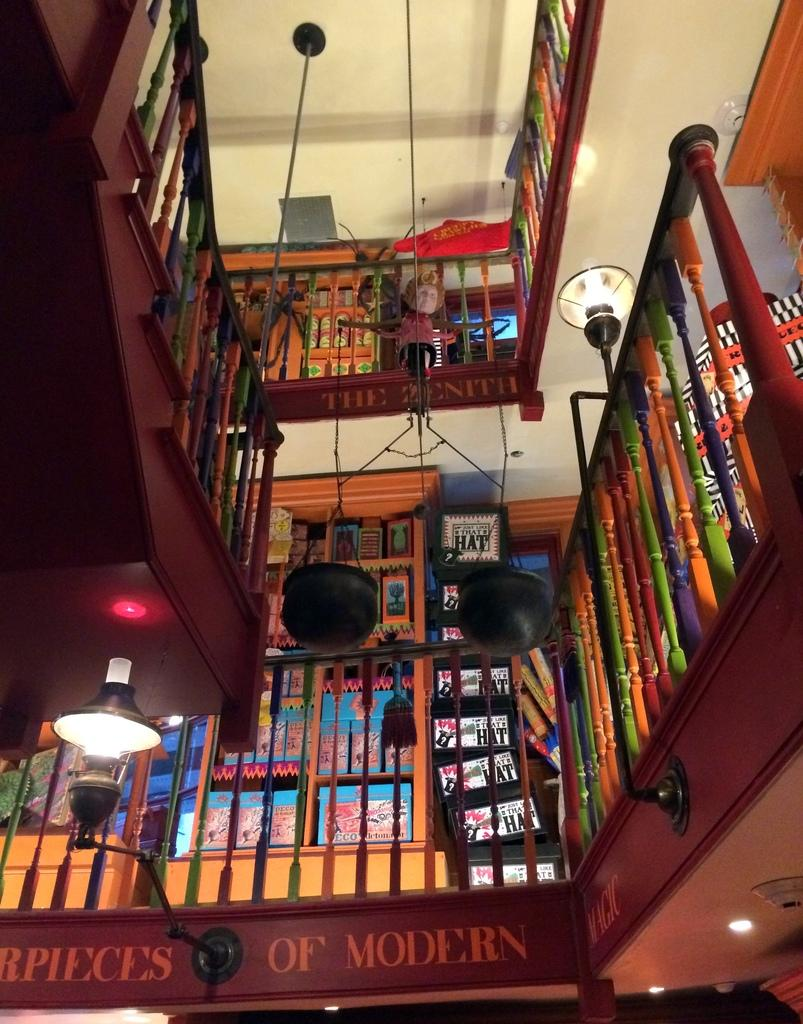Provide a one-sentence caption for the provided image. The railings are multicolored in this library that displays masterpieces of modern magic. 